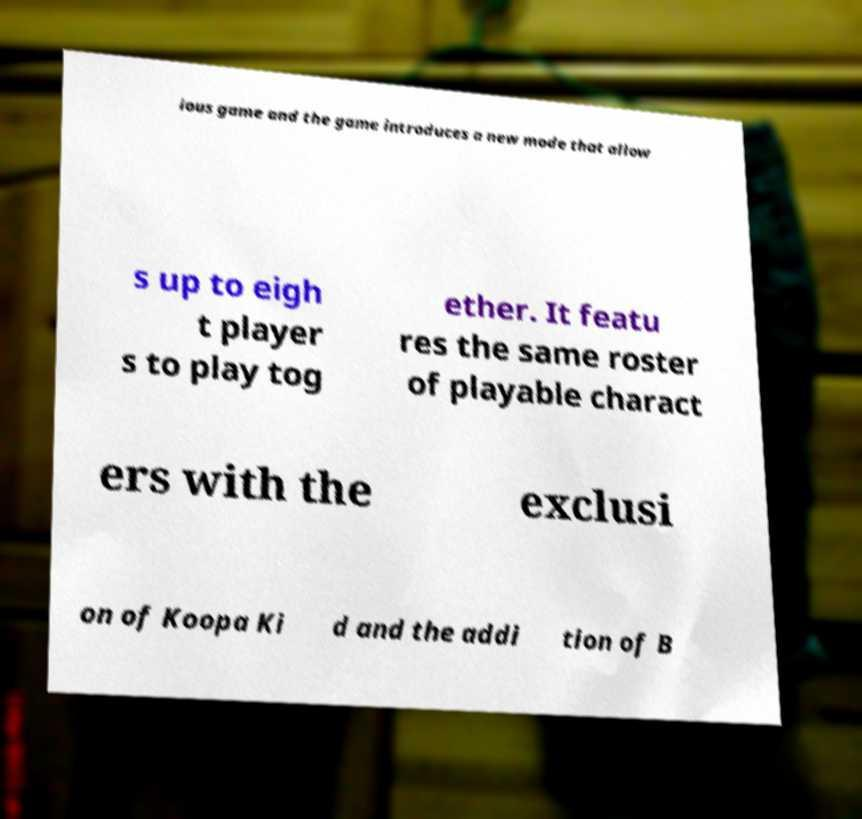Please read and relay the text visible in this image. What does it say? ious game and the game introduces a new mode that allow s up to eigh t player s to play tog ether. It featu res the same roster of playable charact ers with the exclusi on of Koopa Ki d and the addi tion of B 